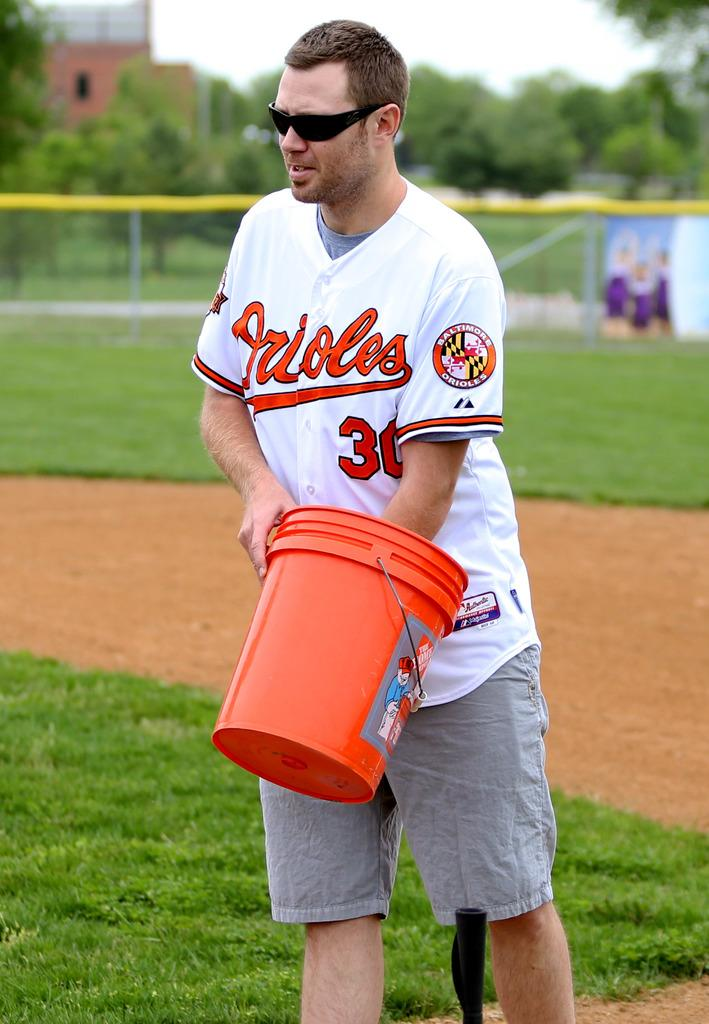<image>
Provide a brief description of the given image. A man in an Orioles shirt with an orange bucket. 